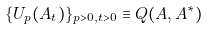<formula> <loc_0><loc_0><loc_500><loc_500>\{ U _ { p } ( A _ { t } ) \} _ { p > 0 , t > 0 } \equiv Q ( A , A ^ { * } )</formula> 